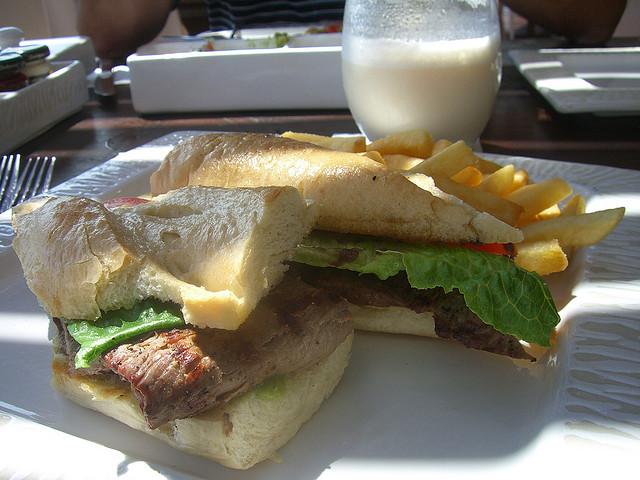Are there any forks on the table?
Concise answer only. Yes. What is served with the fries?
Write a very short answer. Sandwich. Is there meat?
Be succinct. Yes. 